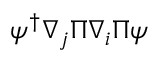<formula> <loc_0><loc_0><loc_500><loc_500>\psi ^ { \dagger } \nabla _ { j } \Pi \nabla _ { i } \Pi \psi</formula> 